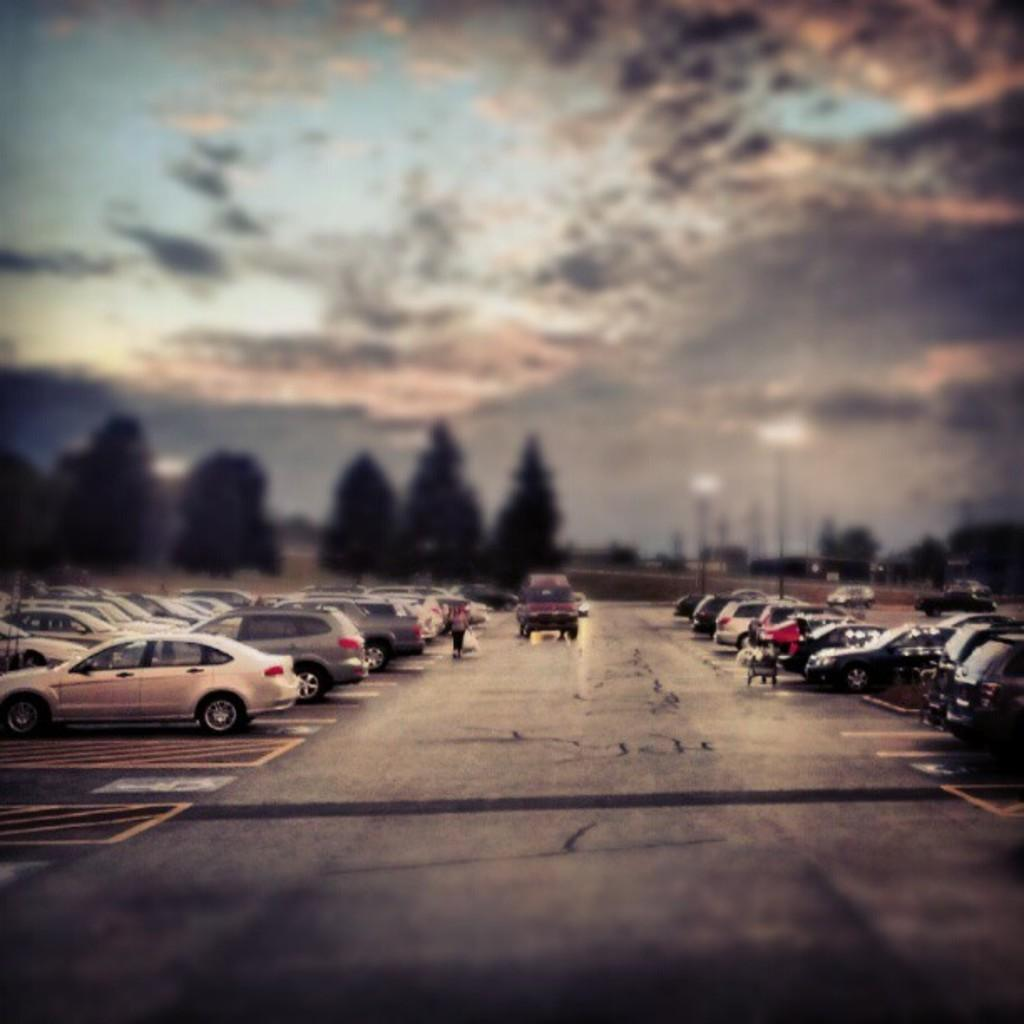What can be seen in the background of the image? The sky is visible in the image. What type of natural elements are present in the image? There are trees in the image. What is the man-made feature visible in the image? Vehicles are parked on the road in the image. How many dimes are scattered on the ground in the image? There are no dimes present in the image. What type of rod can be seen holding up the trees in the image? There are no rods holding up the trees in the image; the trees are standing on their own. 